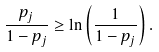<formula> <loc_0><loc_0><loc_500><loc_500>\frac { p _ { j } } { 1 - p _ { j } } \geq \ln \left ( \frac { 1 } { 1 - p _ { j } } \right ) .</formula> 